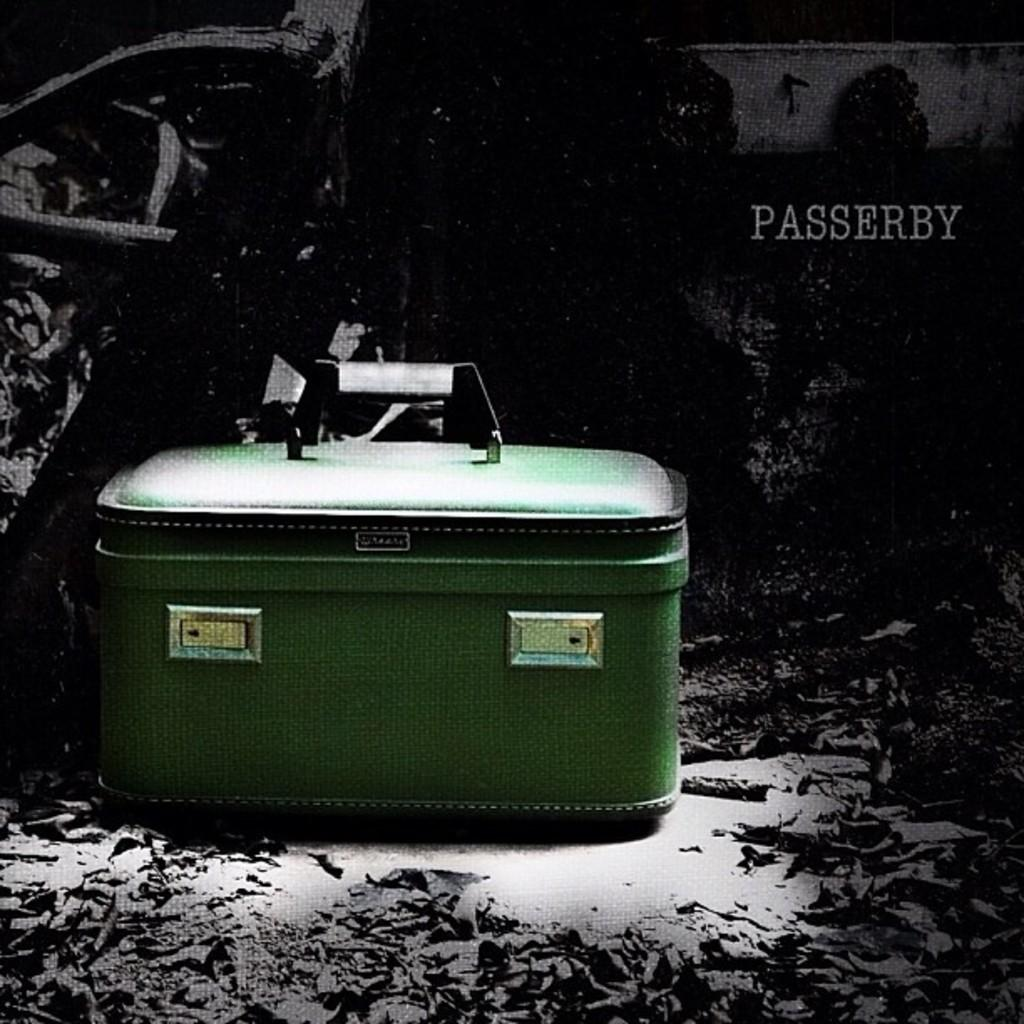What color is the briefcase in the image? The briefcase is green in color. What part of the briefcase is black? The handle of the briefcase is black. Where is the briefcase located in the image? The briefcase is placed on the floor. What words can be seen in the background of the image? The words "pass play" are written in the background. What type of honey is being used to write the words "pass play" in the image? There is no honey present in the image, and the words "pass play" are not written with any substance. 